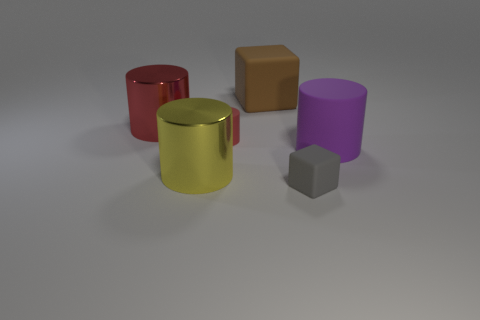Subtract all gray cylinders. Subtract all cyan spheres. How many cylinders are left? 4 Add 1 big cyan objects. How many objects exist? 7 Subtract all blocks. How many objects are left? 4 Subtract all big red rubber cylinders. Subtract all big blocks. How many objects are left? 5 Add 5 gray rubber blocks. How many gray rubber blocks are left? 6 Add 5 large metallic things. How many large metallic things exist? 7 Subtract 0 brown cylinders. How many objects are left? 6 